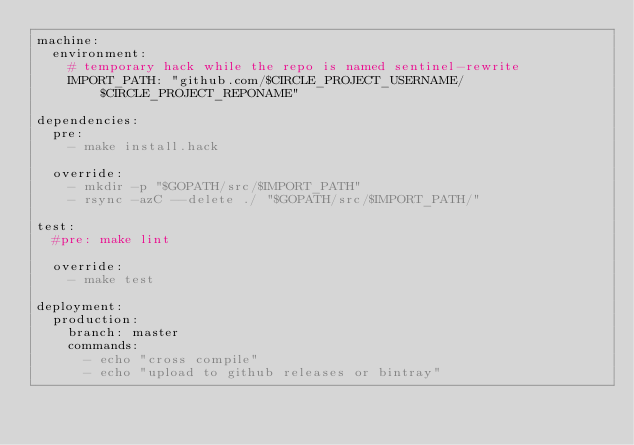Convert code to text. <code><loc_0><loc_0><loc_500><loc_500><_YAML_>machine:
  environment:
    # temporary hack while the repo is named sentinel-rewrite
    IMPORT_PATH: "github.com/$CIRCLE_PROJECT_USERNAME/$CIRCLE_PROJECT_REPONAME"

dependencies:
  pre:
    - make install.hack

  override:
    - mkdir -p "$GOPATH/src/$IMPORT_PATH"
    - rsync -azC --delete ./ "$GOPATH/src/$IMPORT_PATH/"

test:
  #pre: make lint

  override:
    - make test

deployment:
  production:
    branch: master
    commands:
      - echo "cross compile"
      - echo "upload to github releases or bintray"
</code> 